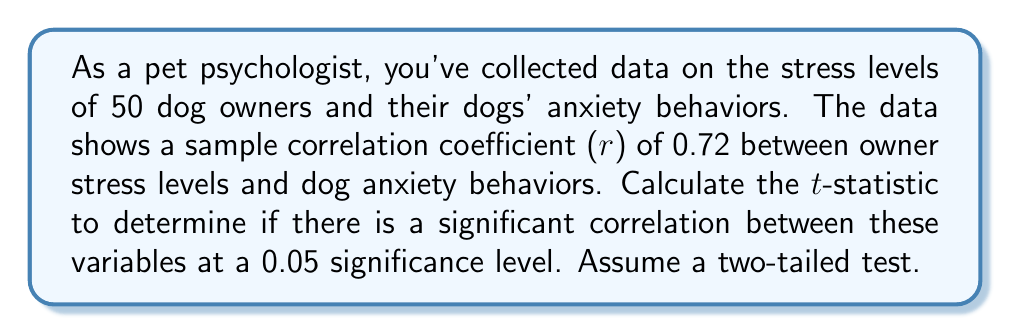What is the answer to this math problem? To determine if there is a significant correlation, we need to calculate the t-statistic and compare it to the critical value from the t-distribution.

Step 1: Calculate the t-statistic using the formula:
$$t = \frac{r\sqrt{n-2}}{\sqrt{1-r^2}}$$
Where:
$r$ = sample correlation coefficient
$n$ = sample size

Step 2: Substitute the given values:
$r = 0.72$
$n = 50$

$$t = \frac{0.72\sqrt{50-2}}{\sqrt{1-0.72^2}}$$

Step 3: Simplify:
$$t = \frac{0.72\sqrt{48}}{\sqrt{1-0.5184}}$$
$$t = \frac{0.72 \cdot 6.9282}{\sqrt{0.4816}}$$
$$t = \frac{4.9883}{0.6940}$$
$$t \approx 7.1877$$

Step 4: Determine the critical value:
For a two-tailed test with α = 0.05 and df = n - 2 = 48, the critical value is approximately ±2.011.

Step 5: Compare the calculated t-statistic to the critical value:
Since |7.1877| > 2.011, we reject the null hypothesis.
Answer: $t \approx 7.1877$ 